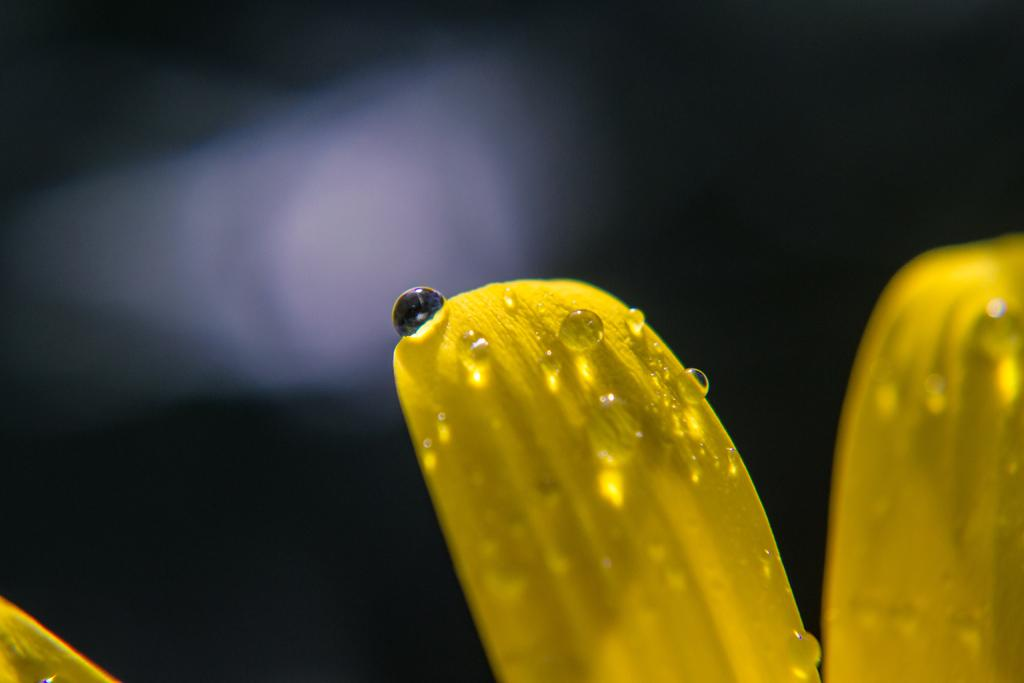What can be seen on the petals in the image? There are droplets of water on petals in the image. What is the color of the background in the image? The background of the image is dark. How many members are on the committee in the image? There is no committee present in the image; it features droplets of water on petals with a dark background. 